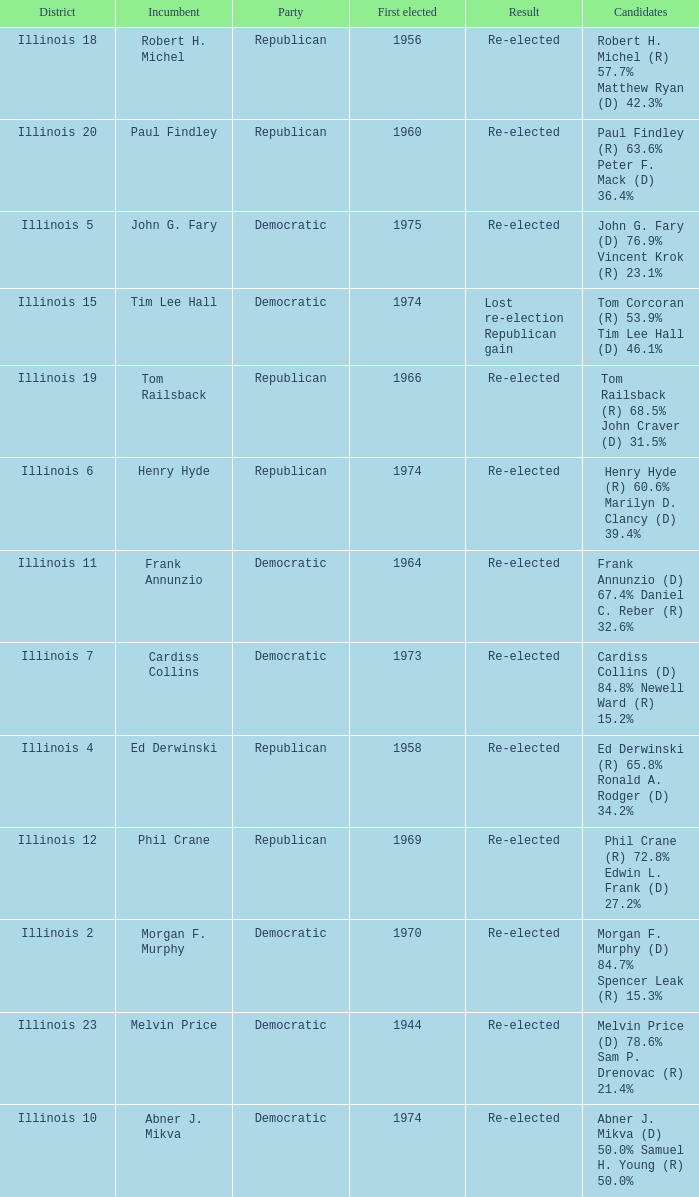Name the first elected for abner j. mikva 1974.0. 